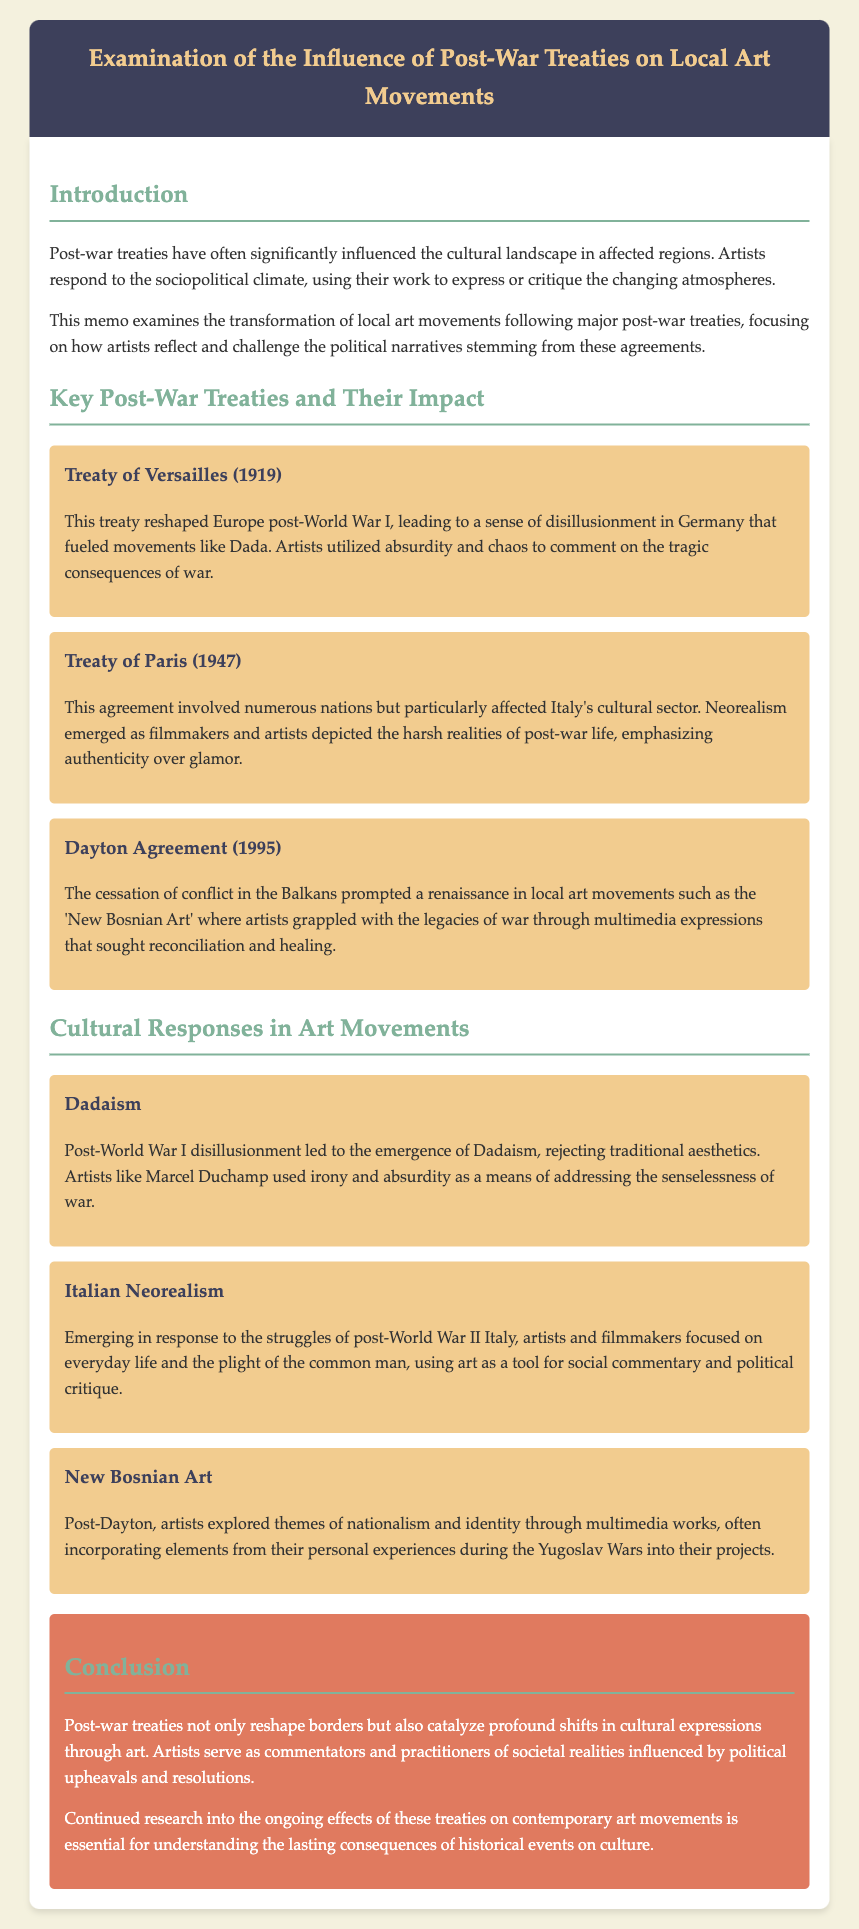What year was the Treaty of Versailles signed? The document states that the Treaty of Versailles was signed in 1919.
Answer: 1919 What art movement emerged in response to the Treaty of Versailles? The document mentions that Dadaism emerged from the disillusionment following the Treaty of Versailles.
Answer: Dadaism Which treaty particularly affected Italy's cultural sector? According to the document, the Treaty of Paris in 1947 particularly affected Italy's cultural sector.
Answer: Treaty of Paris What is the focus of Italian Neorealism? The document indicates that Italian Neorealism focuses on the everyday life and plight of the common man.
Answer: Everyday life What themes did New Bosnian Art explore? The document describes that New Bosnian Art explored themes of nationalism and identity.
Answer: Nationalism and identity Which artist is mentioned in connection with Dadaism? The document specifies Marcel Duchamp as an artist related to Dadaism.
Answer: Marcel Duchamp How did the Dayton Agreement impact local art movements? The document states that the Dayton Agreement prompted a renaissance in local art movements like the 'New Bosnian Art.'
Answer: Renaissance What is a key characteristic of artworks produced in the context of Italian Neorealism? The document notes that authenticity is a key characteristic of artworks produced in the context of Italian Neorealism.
Answer: Authenticity What conclusion does the memo draw about post-war treaties? The memo concludes that post-war treaties catalyze profound shifts in cultural expressions through art.
Answer: Profound shifts in cultural expressions 